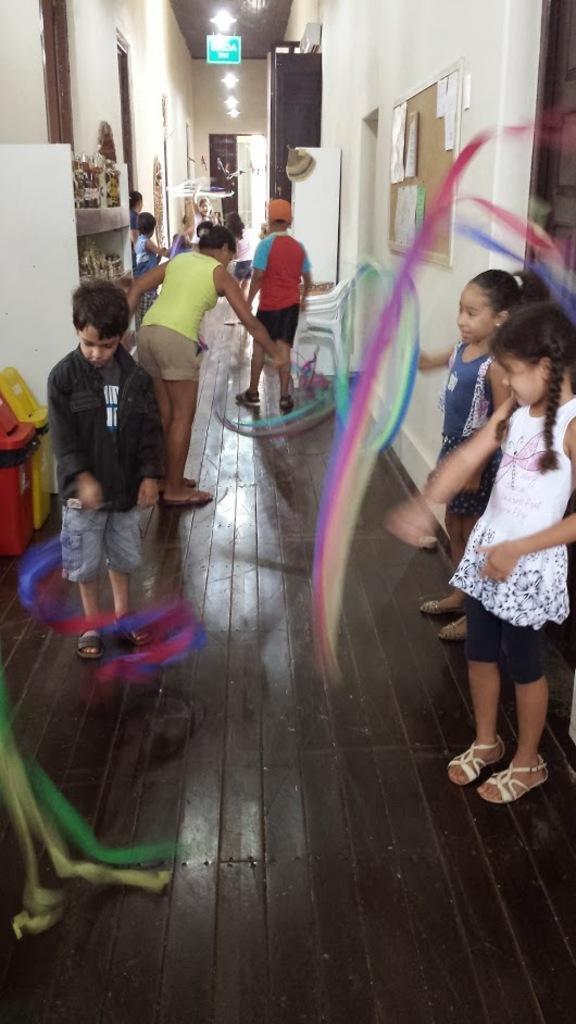Please provide a concise description of this image. In this image there are some kinds and lady standing on the floor, beside them there is a wall with notice board and on other side there is a shelf with some things in it. 